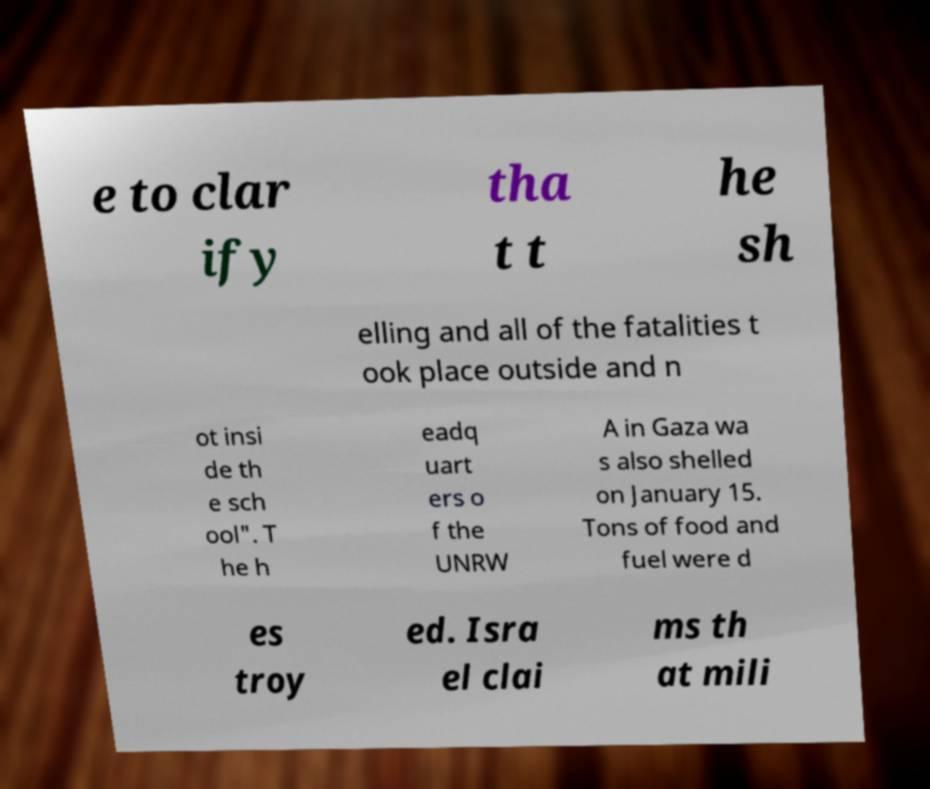Can you read and provide the text displayed in the image?This photo seems to have some interesting text. Can you extract and type it out for me? e to clar ify tha t t he sh elling and all of the fatalities t ook place outside and n ot insi de th e sch ool". T he h eadq uart ers o f the UNRW A in Gaza wa s also shelled on January 15. Tons of food and fuel were d es troy ed. Isra el clai ms th at mili 